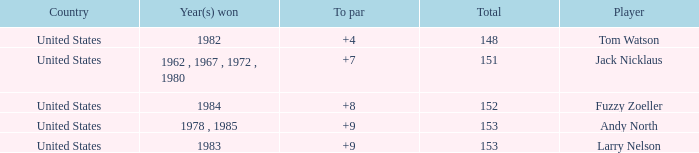What is the Country of the Player with a Total less than 153 and Year(s) won of 1984? United States. 